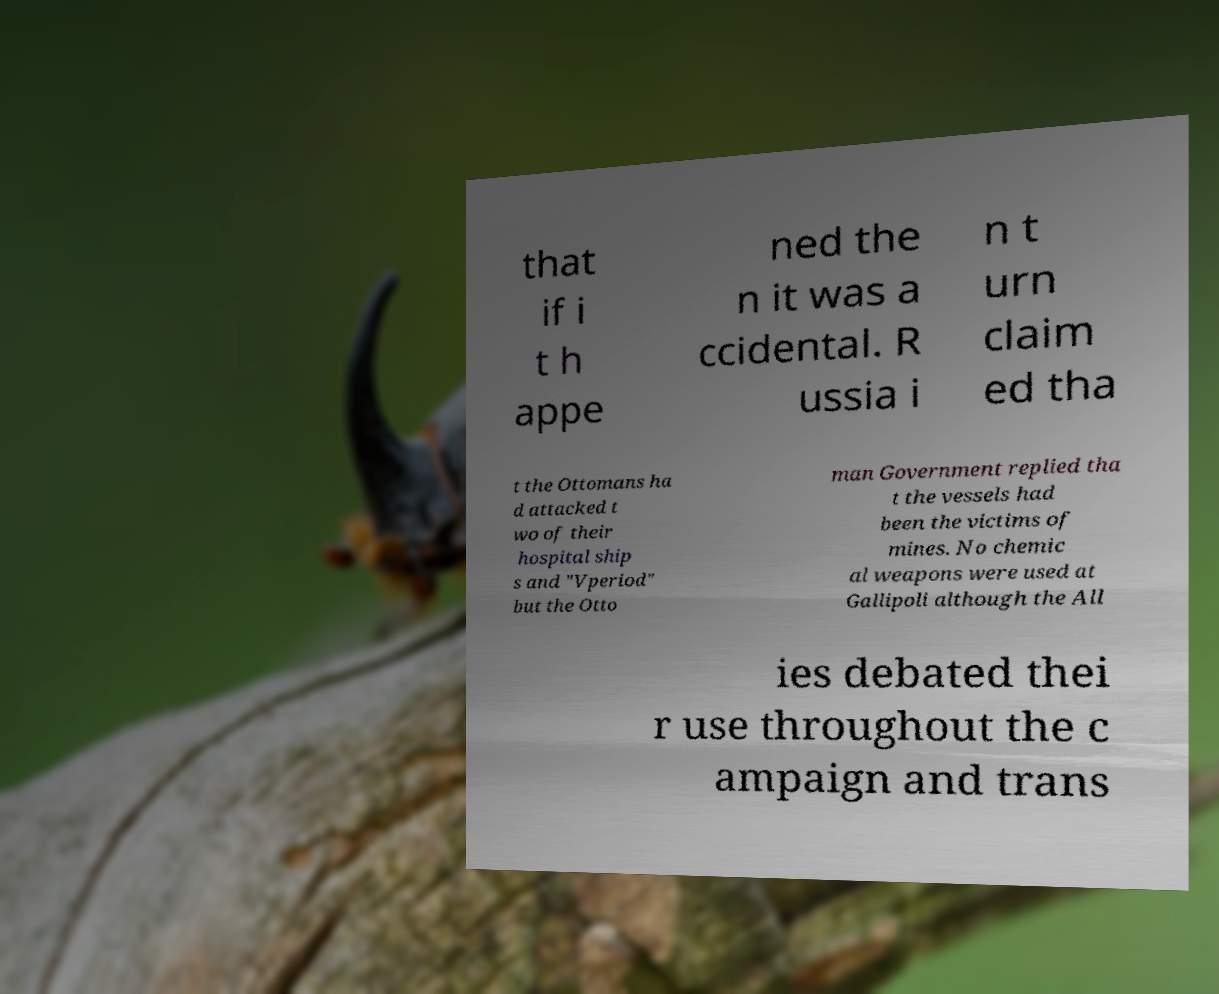Can you read and provide the text displayed in the image?This photo seems to have some interesting text. Can you extract and type it out for me? that if i t h appe ned the n it was a ccidental. R ussia i n t urn claim ed tha t the Ottomans ha d attacked t wo of their hospital ship s and "Vperiod" but the Otto man Government replied tha t the vessels had been the victims of mines. No chemic al weapons were used at Gallipoli although the All ies debated thei r use throughout the c ampaign and trans 